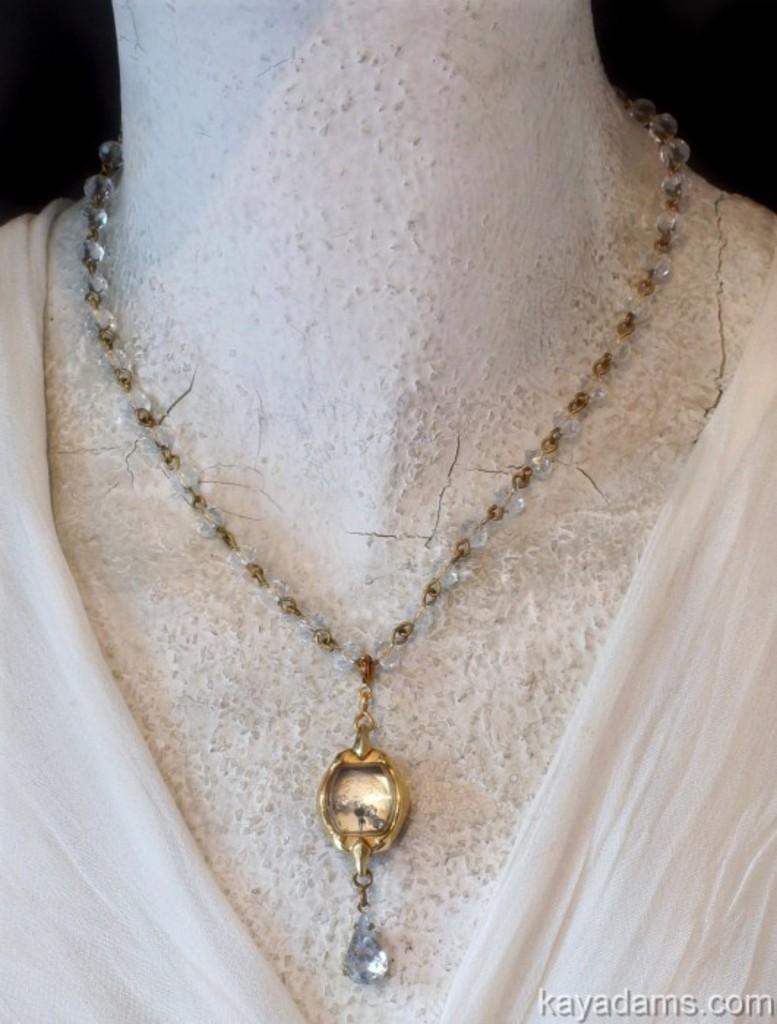What is the main subject of the image? There is a mannequin in the image. What accessory is the mannequin wearing? There is a necklace associated with the mannequin. What type of fabric can be seen in the image? There is a white cloth in the image. What type of bone is visible in the image? There is no bone visible in the image. What type of shoes is the mannequin wearing in the image? The provided facts do not mention any shoes associated with the mannequin. --- Facts: 1. There is a person sitting on a chair in the image. 2. The person is holding a book. 3. There is a table next to the chair. 4. There is a lamp on the table. Absurd Topics: parrot, ocean, bicycle Conversation: What is the person in the image doing? There is a person sitting on a chair in the image. What object is the person holding? The person is holding a book. What piece of furniture is next to the chair? There is a table next to the chair. What is on the table? There is a lamp on the table. Reasoning: Let's think step by step in order to produce the conversation. We start by identifying the main subject of the image, which is the person sitting on a chair. Then, we describe the object that the person is holding, which is a book. Next, we mention the presence of a table next to the chair. Finally, we describe the object on the table, which is a lamp. Each question is designed to elicit a specific detail about the image that is known from the provided facts. Absurd Question/Answer: Can you see a parrot sitting on the person's shoulder in the image? There is no parrot visible in the image. What type of ocean can be seen in the background of the image? The provided facts do not mention any ocean or background in the image. 